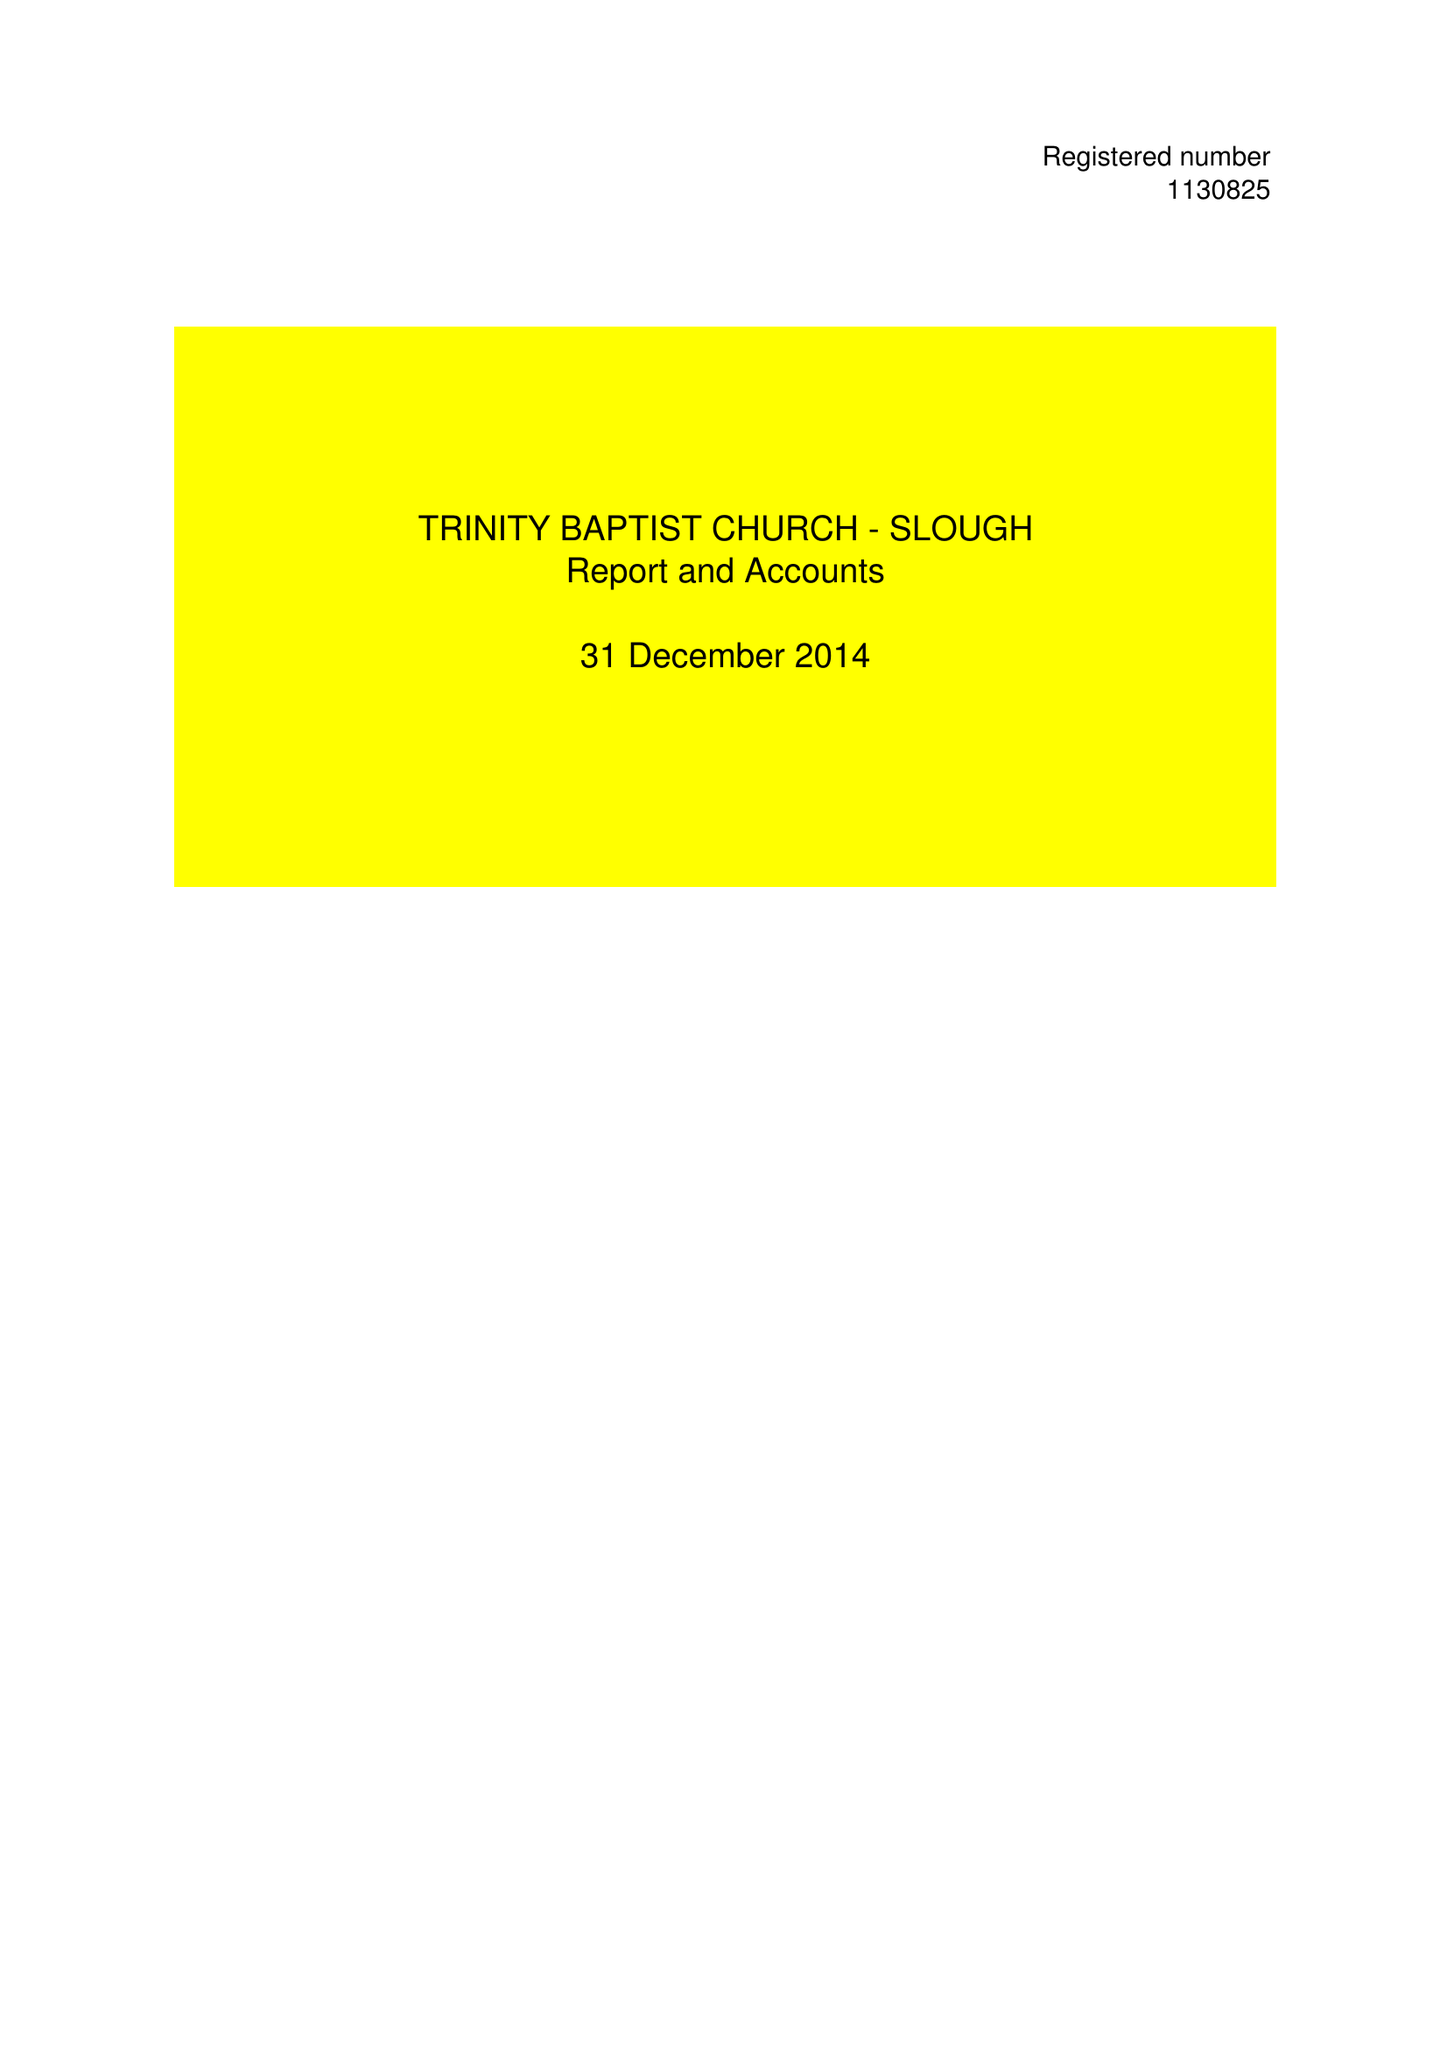What is the value for the charity_number?
Answer the question using a single word or phrase. 1130825 